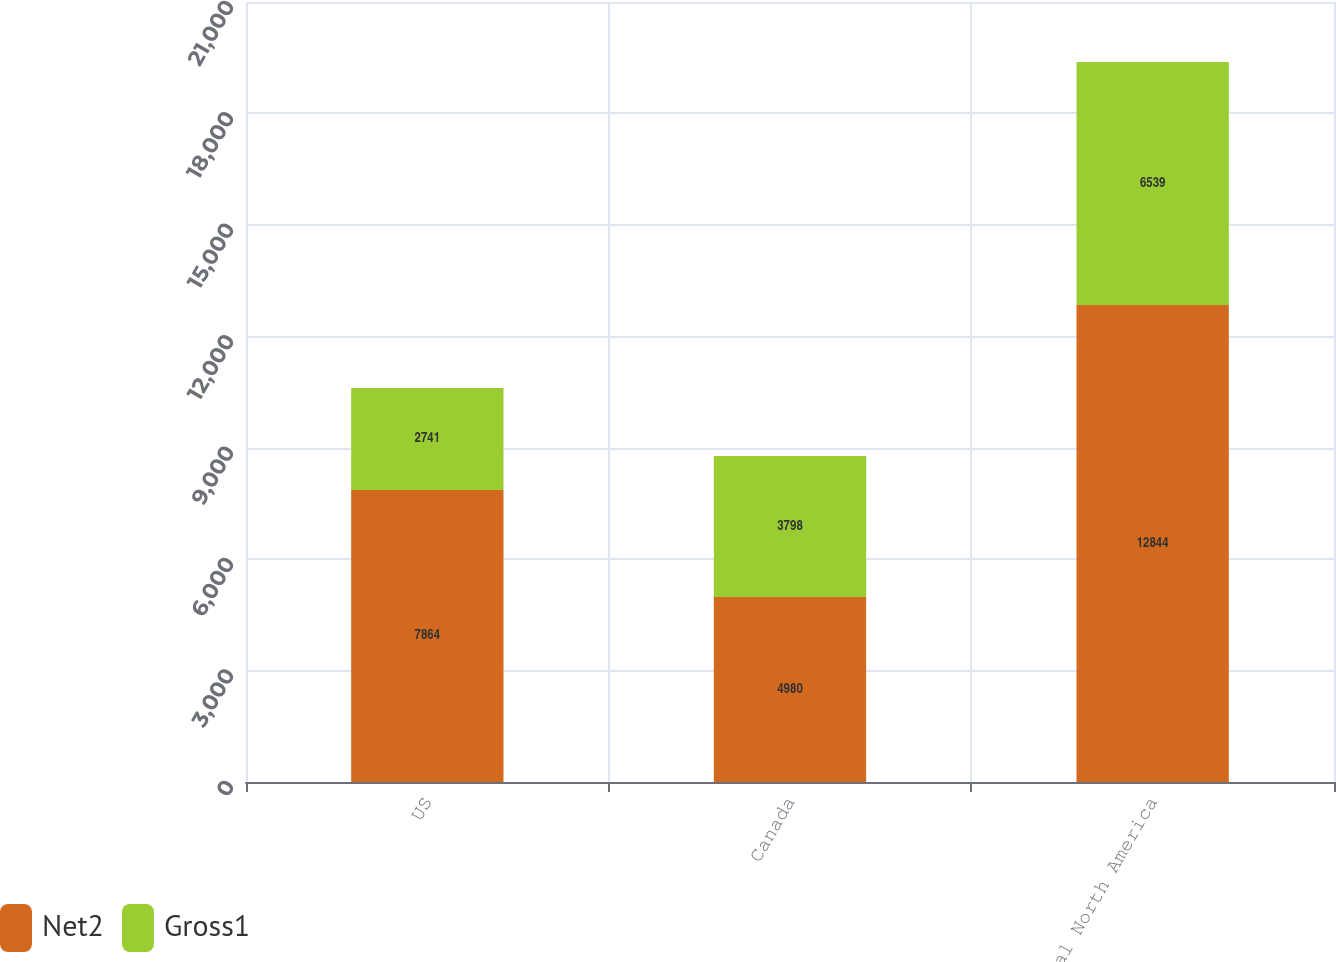Convert chart. <chart><loc_0><loc_0><loc_500><loc_500><stacked_bar_chart><ecel><fcel>US<fcel>Canada<fcel>Total North America<nl><fcel>Net2<fcel>7864<fcel>4980<fcel>12844<nl><fcel>Gross1<fcel>2741<fcel>3798<fcel>6539<nl></chart> 